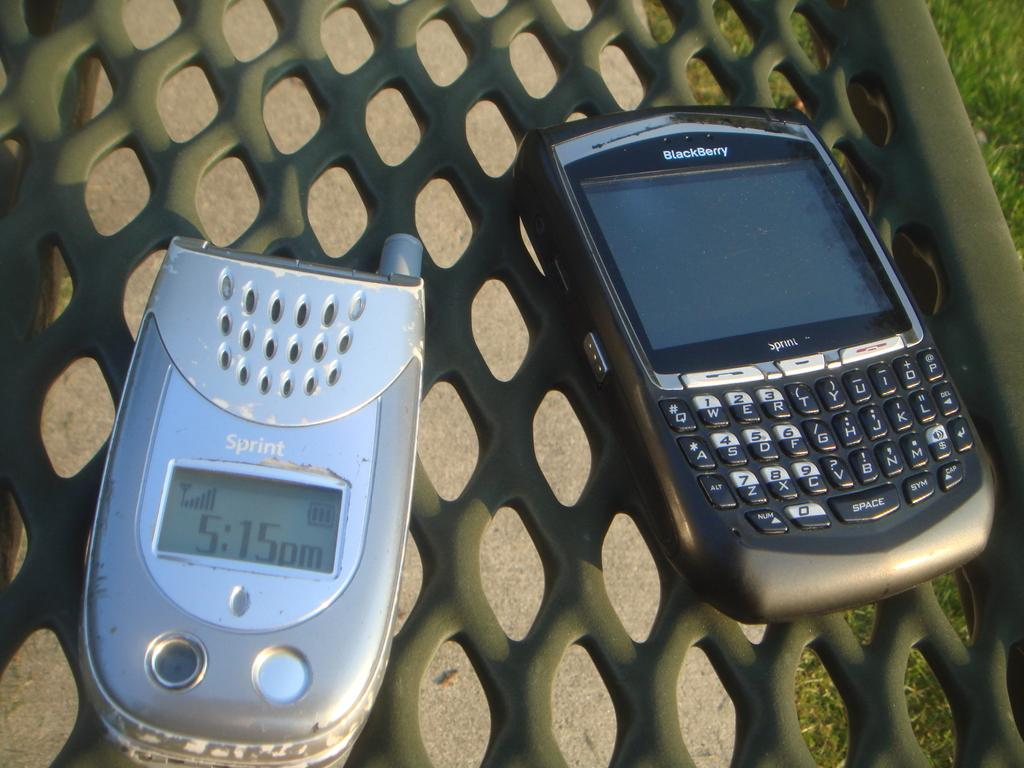Provide a one-sentence caption for the provided image. A flip phone that says Sprint and a smartphone that says Blackberry is next to it on a bench. 